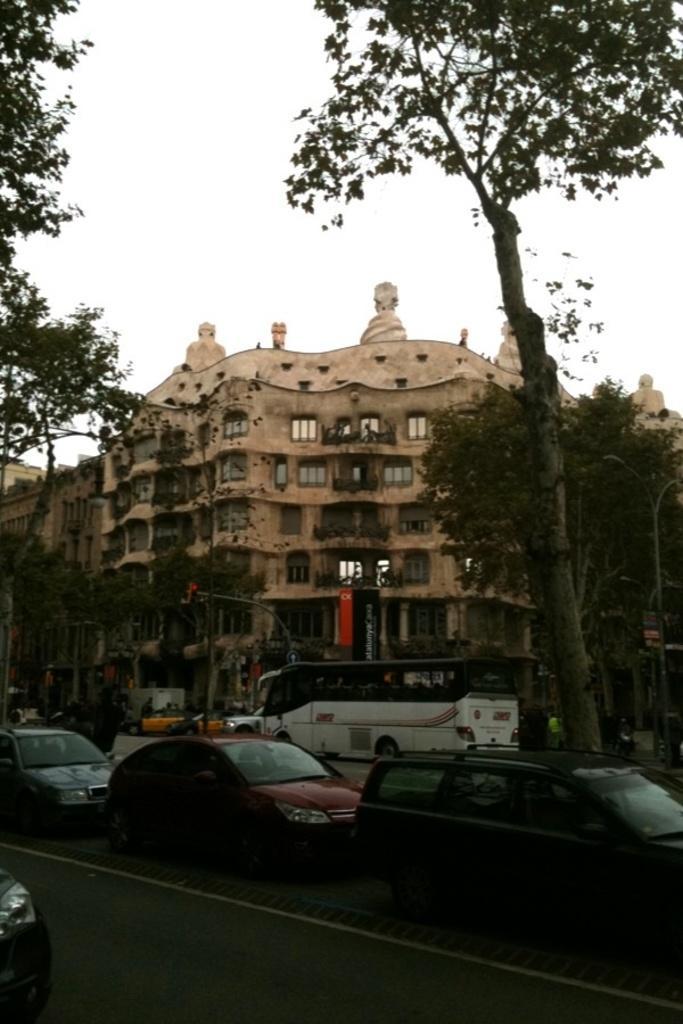Could you give a brief overview of what you see in this image? In the image we can see there are cars and a bus are parked on the road and there are trees. There are buildings and there is a clear sky. 